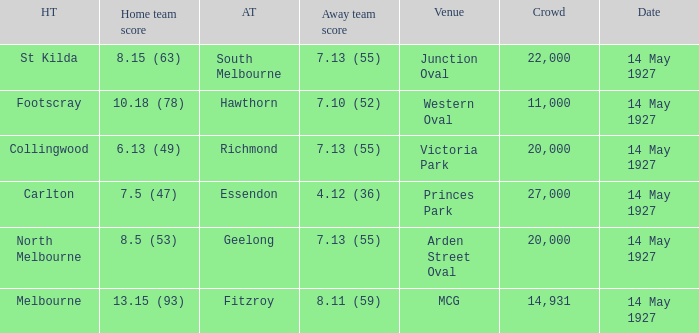On what date does Essendon play as the away team? 14 May 1927. 